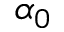Convert formula to latex. <formula><loc_0><loc_0><loc_500><loc_500>\alpha _ { 0 }</formula> 